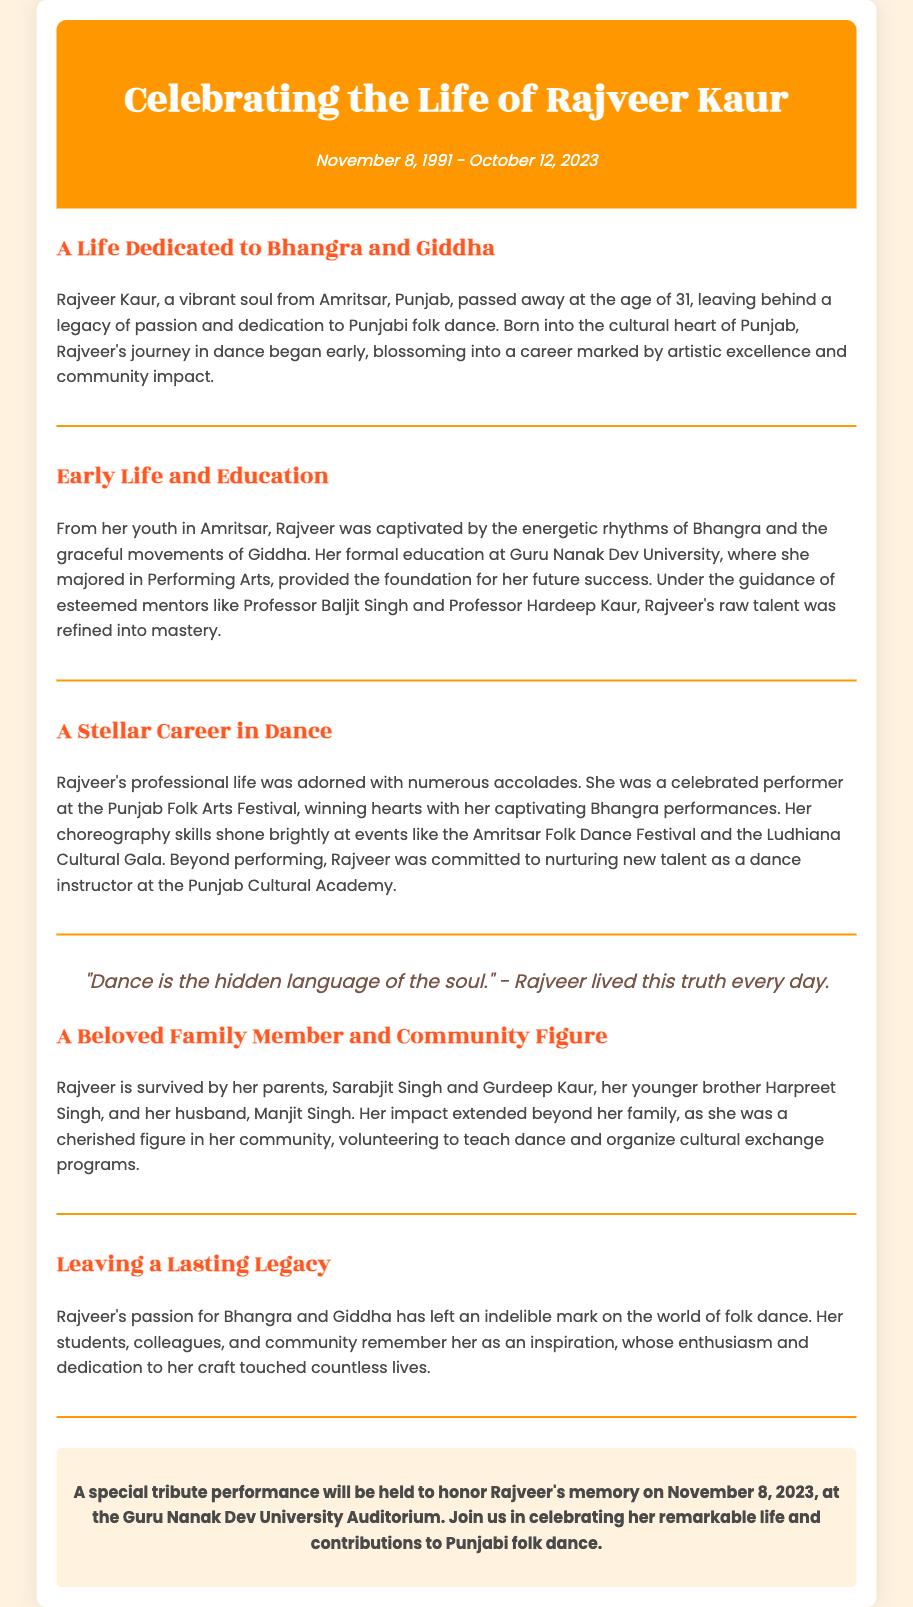what is the full name of the dancer celebrated in the document? The full name of the dancer celebrated in the obituary is mentioned in the title and header, which is “Rajveer Kaur.”
Answer: Rajveer Kaur what were the years of Rajveer Kaur’s life? The dates of Rajveer Kaur's life are found in the header, indicating her birth and passing.
Answer: November 8, 1991 - October 12, 2023 which university did Rajveer Kaur attend? The document states that Rajveer Kaur attended "Guru Nanak Dev University" for her education in Performing Arts.
Answer: Guru Nanak Dev University how old was Rajveer Kaur when she passed away? Rajveer Kaur's age at the time of her passing can be calculated from the birth date and death date mentioned in the header.
Answer: 31 who were Rajveer Kaur's notable mentors? The obituary highlights two mentors who guided Rajveer Kaur in her dance journey: "Professor Baljit Singh and Professor Hardeep Kaur."
Answer: Professor Baljit Singh and Professor Hardeep Kaur what cultural activities was Rajveer involved in besides performing? The obituary mentions that Rajveer Kaur was committed to nurturing new talent and organized cultural exchange programs in her community.
Answer: Teaching dance and organizing cultural exchange programs when is the tribute performance scheduled? The tribute performance date is provided in the memorial information section of the document.
Answer: November 8, 2023 what kind of dance did Rajveer Kaur specialize in? The document states that Rajveer Kaur was dedicated to Punjabi folk dance, specifically Bhangra and Giddha.
Answer: Bhangra and Giddha what legacy did Rajveer Kaur leave behind? The obituary indicates that Rajveer Kaur left a lasting legacy in folk dance, remembered as an inspiration by her students, colleagues, and community.
Answer: A lasting legacy in folk dance 